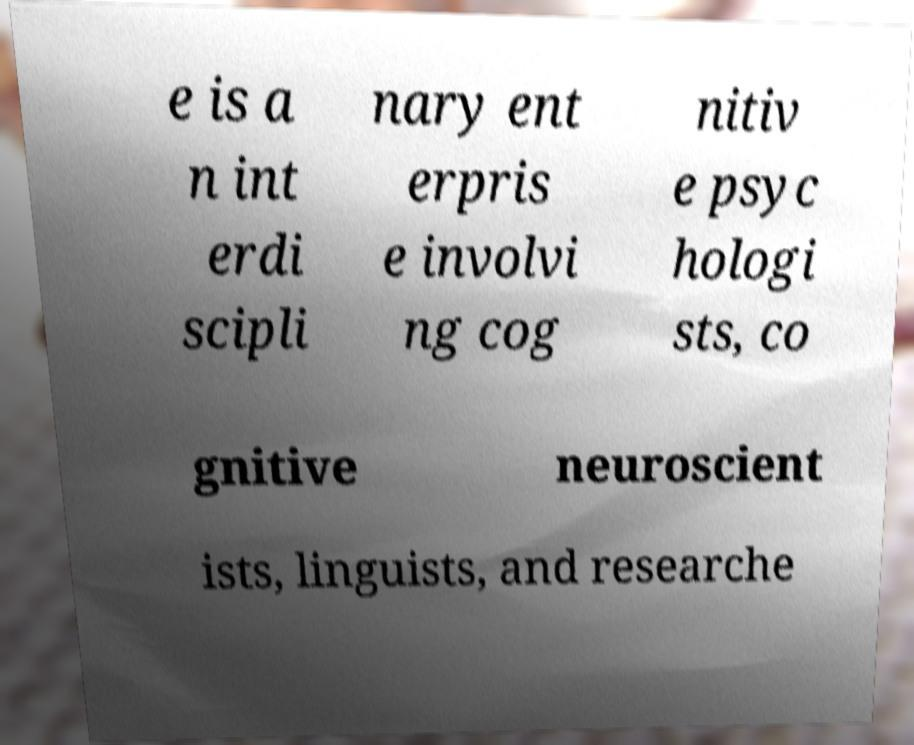What messages or text are displayed in this image? I need them in a readable, typed format. e is a n int erdi scipli nary ent erpris e involvi ng cog nitiv e psyc hologi sts, co gnitive neuroscient ists, linguists, and researche 